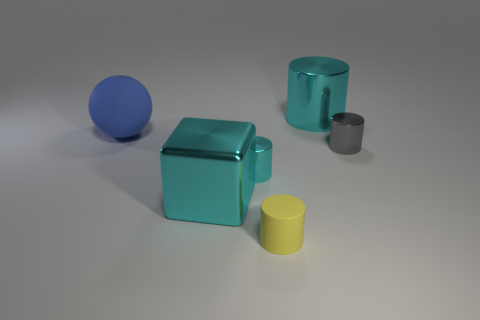Is the size of the matte cylinder the same as the blue thing?
Ensure brevity in your answer.  No. What number of objects are either gray metallic cylinders or cyan metal cylinders that are right of the big cube?
Make the answer very short. 3. What is the material of the cylinder that is the same size as the blue object?
Your answer should be compact. Metal. There is a large thing that is behind the large cyan shiny block and to the left of the yellow matte thing; what is its material?
Offer a terse response. Rubber. Are there any big blocks right of the matte object right of the big cyan block?
Provide a short and direct response. No. There is a cyan object that is in front of the big blue matte object and behind the large cyan metallic block; how big is it?
Your response must be concise. Small. What number of yellow objects are either small rubber objects or metal objects?
Provide a succinct answer. 1. What shape is the blue matte object that is the same size as the metallic cube?
Provide a short and direct response. Sphere. How many other things are there of the same color as the rubber ball?
Ensure brevity in your answer.  0. There is a gray object that is to the right of the object that is in front of the big metal cube; what size is it?
Keep it short and to the point. Small. 